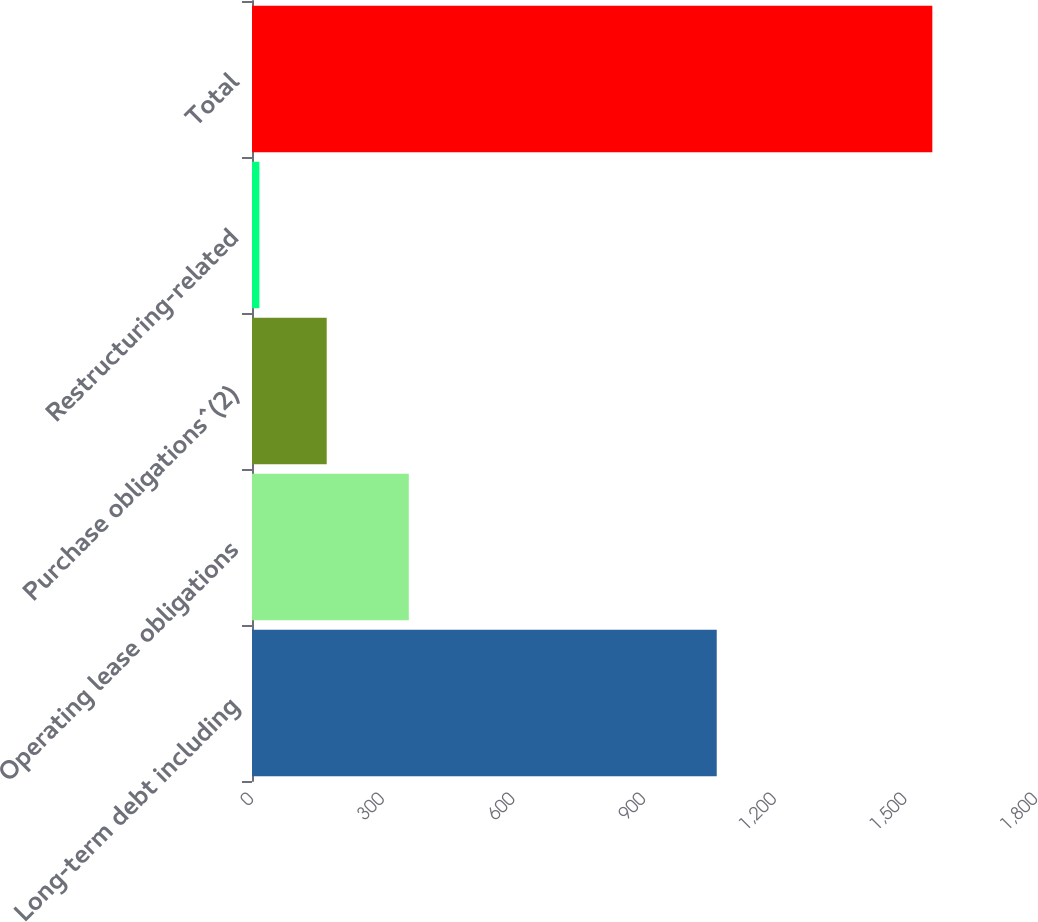<chart> <loc_0><loc_0><loc_500><loc_500><bar_chart><fcel>Long-term debt including<fcel>Operating lease obligations<fcel>Purchase obligations^(2)<fcel>Restructuring-related<fcel>Total<nl><fcel>1067<fcel>360<fcel>171.5<fcel>17<fcel>1562<nl></chart> 